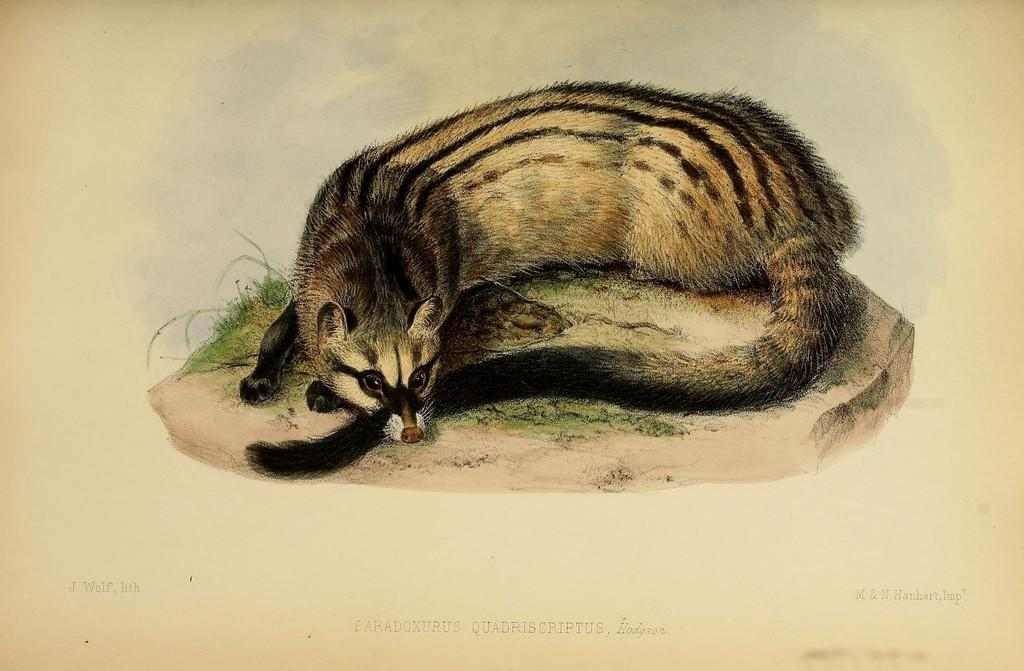What is depicted in the image? There is a picture of an animal in the image. What is the animal doing in the image? The animal is lying on the ground. What type of environment is visible in the image? Grass is present in the image. What type of fire can be seen in the image? There is no fire present in the image; it features a picture of an animal lying on the ground in a grassy environment. 